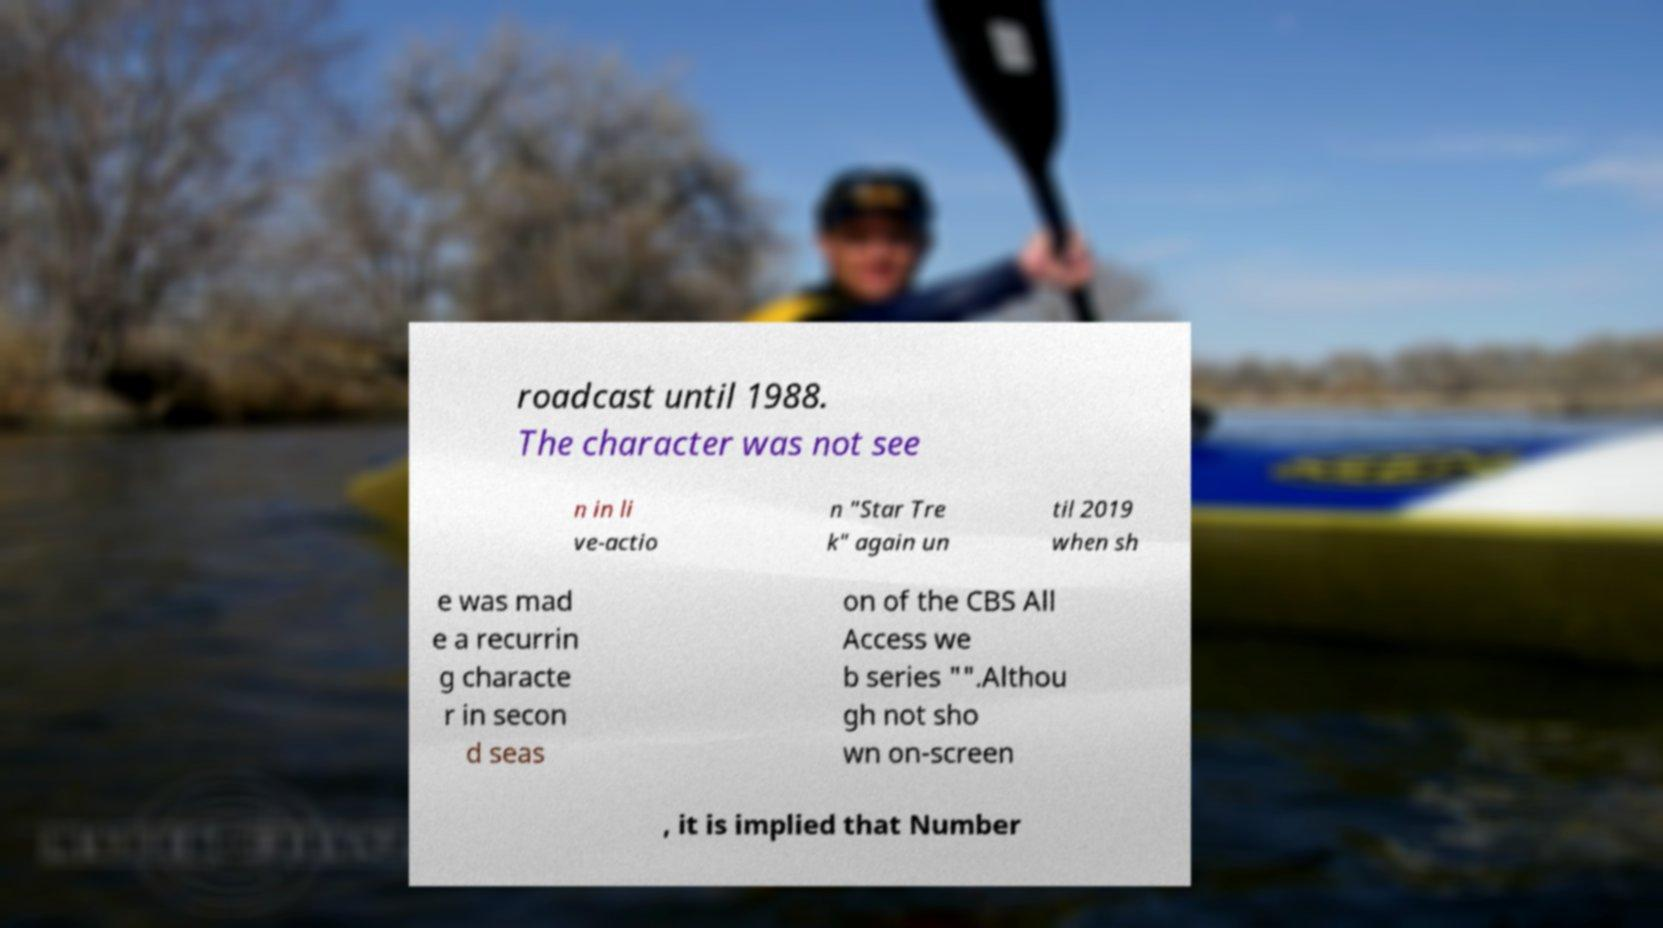What messages or text are displayed in this image? I need them in a readable, typed format. roadcast until 1988. The character was not see n in li ve-actio n "Star Tre k" again un til 2019 when sh e was mad e a recurrin g characte r in secon d seas on of the CBS All Access we b series "".Althou gh not sho wn on-screen , it is implied that Number 